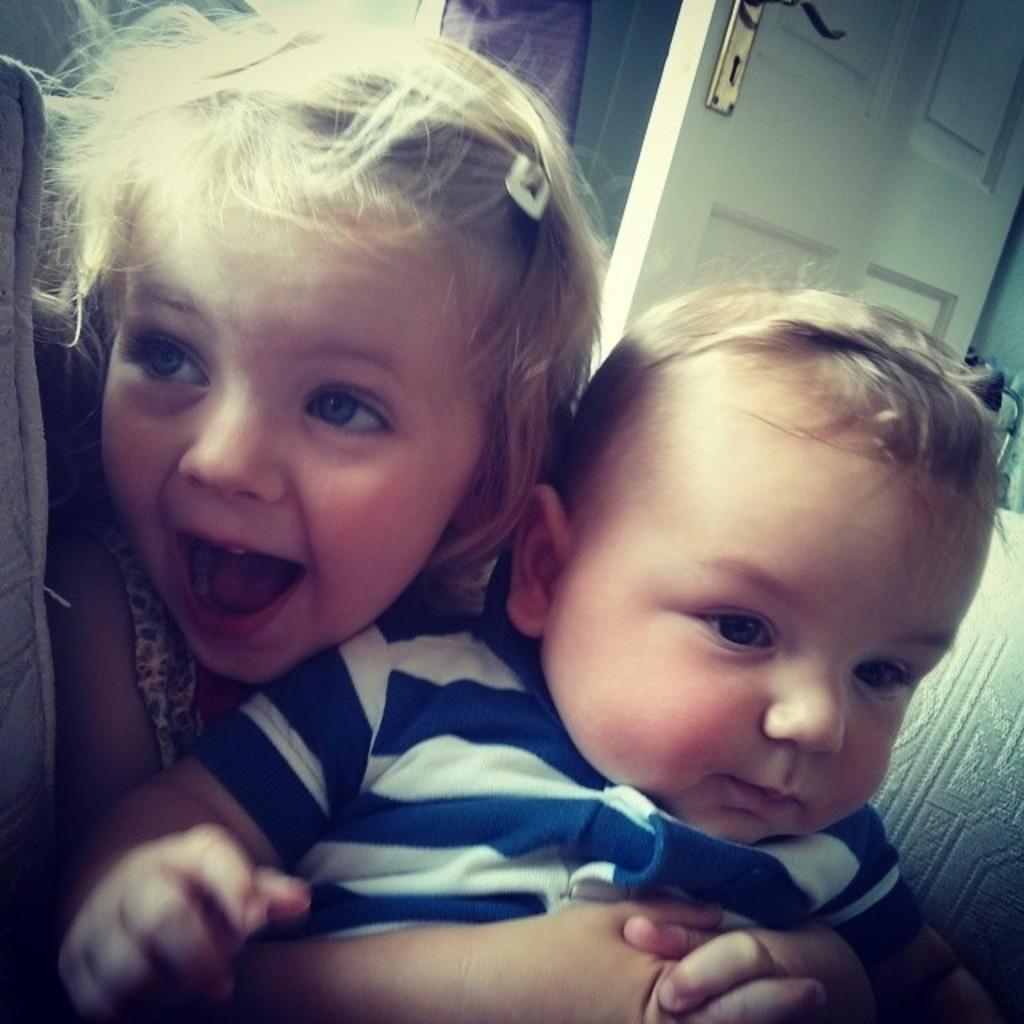In one or two sentences, can you explain what this image depicts? In this image two children are sitting on the sofa. At the back side there is a door. 